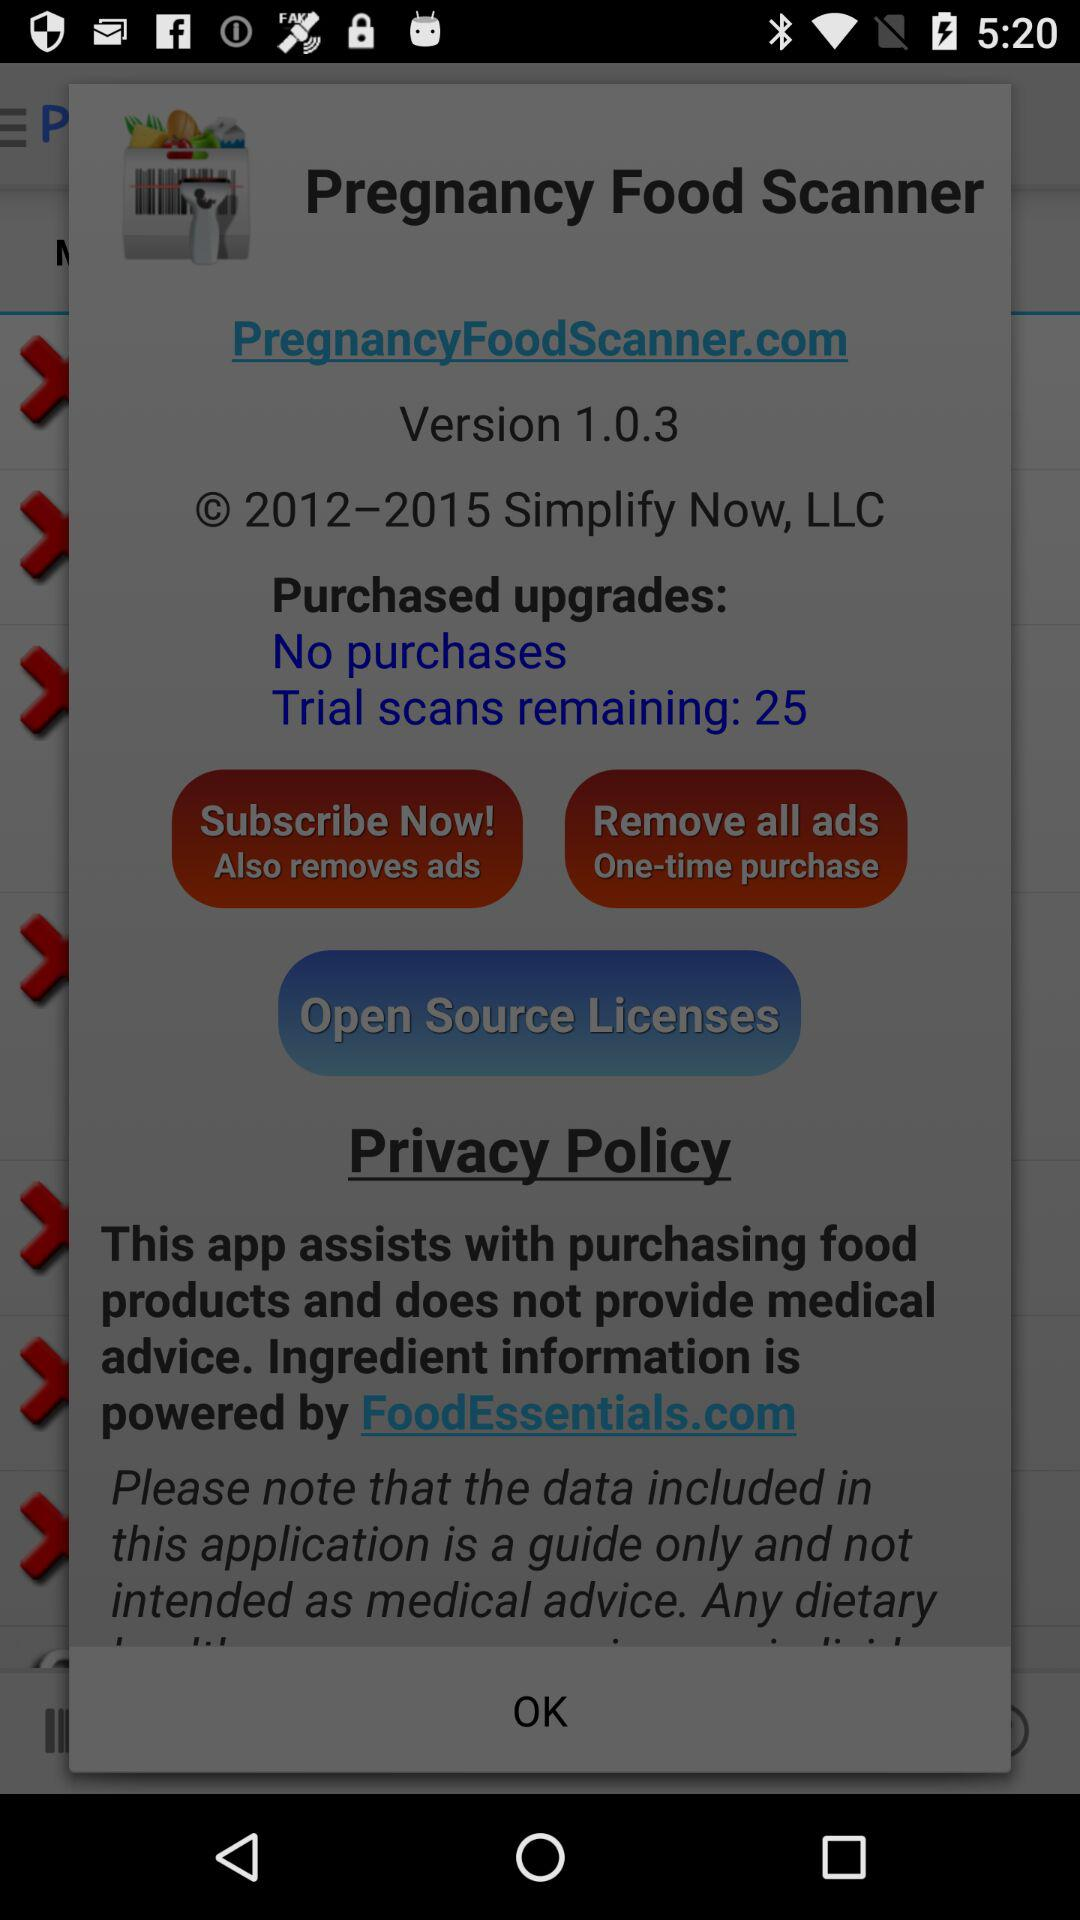What is the remaining number of trial scans? The remaining number of trial scans is 25. 